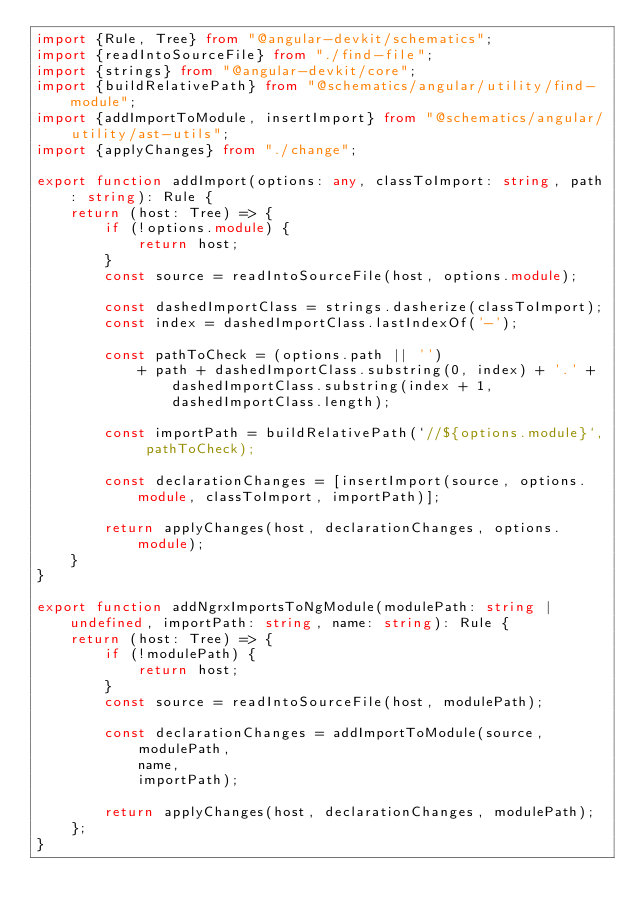Convert code to text. <code><loc_0><loc_0><loc_500><loc_500><_TypeScript_>import {Rule, Tree} from "@angular-devkit/schematics";
import {readIntoSourceFile} from "./find-file";
import {strings} from "@angular-devkit/core";
import {buildRelativePath} from "@schematics/angular/utility/find-module";
import {addImportToModule, insertImport} from "@schematics/angular/utility/ast-utils";
import {applyChanges} from "./change";

export function addImport(options: any, classToImport: string, path: string): Rule {
    return (host: Tree) => {
        if (!options.module) {
            return host;
        }
        const source = readIntoSourceFile(host, options.module);

        const dashedImportClass = strings.dasherize(classToImport);
        const index = dashedImportClass.lastIndexOf('-');

        const pathToCheck = (options.path || '')
            + path + dashedImportClass.substring(0, index) + '.' + dashedImportClass.substring(index + 1, dashedImportClass.length);

        const importPath = buildRelativePath(`//${options.module}`, pathToCheck);

        const declarationChanges = [insertImport(source, options.module, classToImport, importPath)];

        return applyChanges(host, declarationChanges, options.module);
    }
}

export function addNgrxImportsToNgModule(modulePath: string | undefined, importPath: string, name: string): Rule {
    return (host: Tree) => {
        if (!modulePath) {
            return host;
        }
        const source = readIntoSourceFile(host, modulePath);

        const declarationChanges = addImportToModule(source,
            modulePath,
            name,
            importPath);

        return applyChanges(host, declarationChanges, modulePath);
    };
}
</code> 